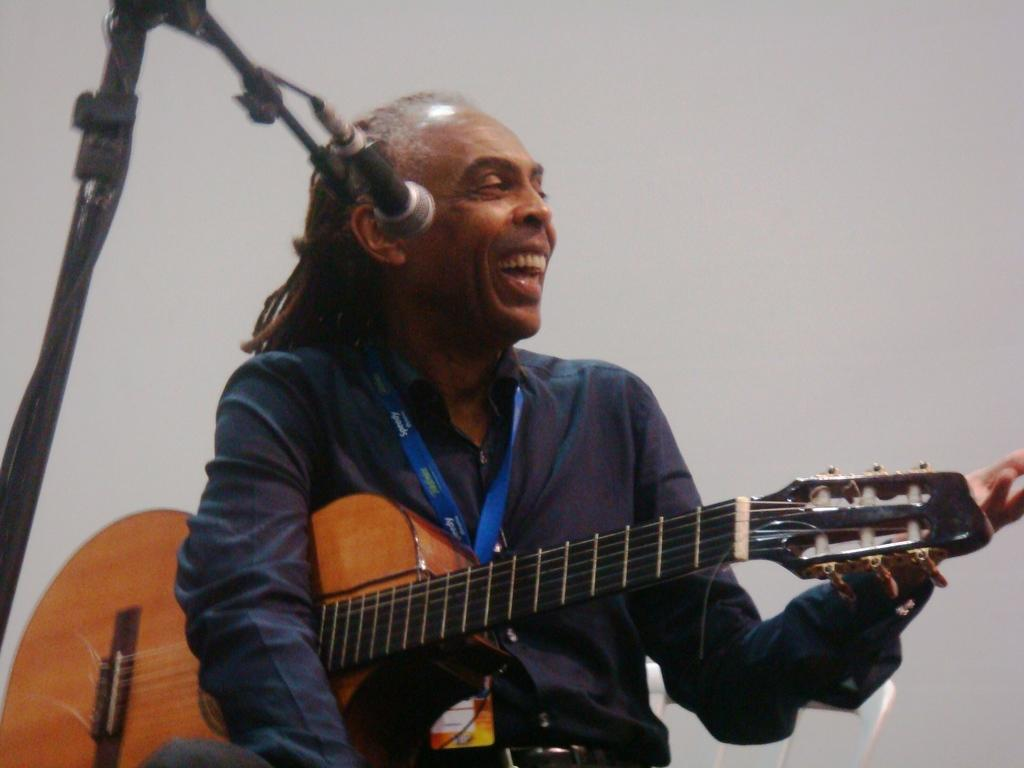What is the person in the image doing? The person is sitting in the image. What expression does the person have? The person is smiling. What object is the person holding? The person is holding a guitar. What can be seen on the left side of the image? There is a microphone on the left side of the image. What type of pig can be seen playing the guitar in the image? There is no pig present in the image, and therefore no such activity can be observed. 